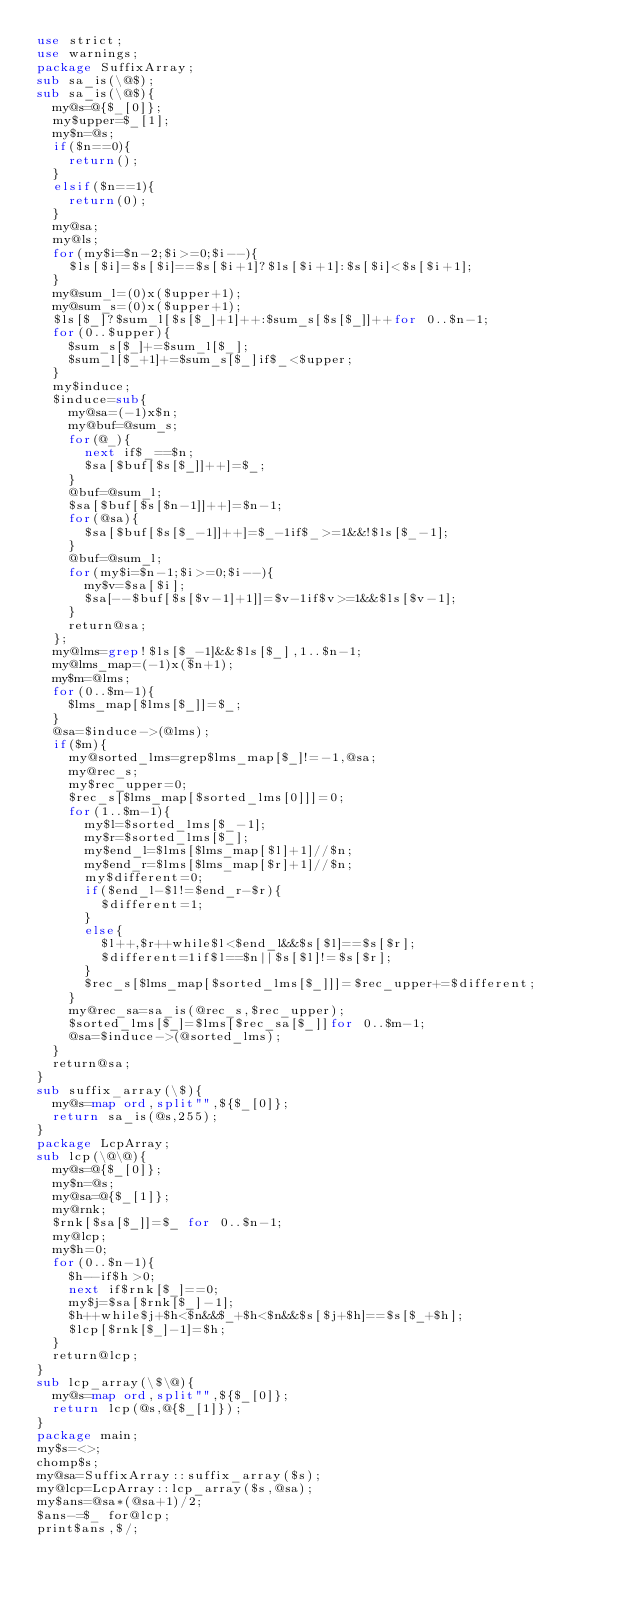<code> <loc_0><loc_0><loc_500><loc_500><_Perl_>use strict;
use warnings;
package SuffixArray;
sub sa_is(\@$);
sub sa_is(\@$){
	my@s=@{$_[0]};
	my$upper=$_[1];
	my$n=@s;
	if($n==0){
		return();
	}
	elsif($n==1){
		return(0);
	}
	my@sa;
	my@ls;
	for(my$i=$n-2;$i>=0;$i--){
		$ls[$i]=$s[$i]==$s[$i+1]?$ls[$i+1]:$s[$i]<$s[$i+1];
	}
	my@sum_l=(0)x($upper+1);
	my@sum_s=(0)x($upper+1);
	$ls[$_]?$sum_l[$s[$_]+1]++:$sum_s[$s[$_]]++for 0..$n-1;
	for(0..$upper){
		$sum_s[$_]+=$sum_l[$_];
		$sum_l[$_+1]+=$sum_s[$_]if$_<$upper;
	}
	my$induce;
	$induce=sub{
		my@sa=(-1)x$n;
		my@buf=@sum_s;
		for(@_){
			next if$_==$n;
			$sa[$buf[$s[$_]]++]=$_;
		}
		@buf=@sum_l;
		$sa[$buf[$s[$n-1]]++]=$n-1;
		for(@sa){
			$sa[$buf[$s[$_-1]]++]=$_-1if$_>=1&&!$ls[$_-1];
		}
		@buf=@sum_l;
		for(my$i=$n-1;$i>=0;$i--){
			my$v=$sa[$i];
			$sa[--$buf[$s[$v-1]+1]]=$v-1if$v>=1&&$ls[$v-1];
		}
		return@sa;
	};
	my@lms=grep!$ls[$_-1]&&$ls[$_],1..$n-1;
	my@lms_map=(-1)x($n+1);
	my$m=@lms;
	for(0..$m-1){
		$lms_map[$lms[$_]]=$_;
	}
	@sa=$induce->(@lms);
	if($m){
		my@sorted_lms=grep$lms_map[$_]!=-1,@sa;
		my@rec_s;
		my$rec_upper=0;
		$rec_s[$lms_map[$sorted_lms[0]]]=0;
		for(1..$m-1){
			my$l=$sorted_lms[$_-1];
			my$r=$sorted_lms[$_];
			my$end_l=$lms[$lms_map[$l]+1]//$n;
			my$end_r=$lms[$lms_map[$r]+1]//$n;
			my$different=0;
			if($end_l-$l!=$end_r-$r){
				$different=1;
			}
			else{
				$l++,$r++while$l<$end_l&&$s[$l]==$s[$r];
				$different=1if$l==$n||$s[$l]!=$s[$r];
			}
			$rec_s[$lms_map[$sorted_lms[$_]]]=$rec_upper+=$different;
		}
		my@rec_sa=sa_is(@rec_s,$rec_upper);
		$sorted_lms[$_]=$lms[$rec_sa[$_]]for 0..$m-1;
		@sa=$induce->(@sorted_lms);
	}
	return@sa;
}
sub suffix_array(\$){
	my@s=map ord,split"",${$_[0]};
	return sa_is(@s,255);
}
package LcpArray;
sub lcp(\@\@){
	my@s=@{$_[0]};
	my$n=@s;
	my@sa=@{$_[1]};
	my@rnk;
	$rnk[$sa[$_]]=$_ for 0..$n-1;
	my@lcp;
	my$h=0;
	for(0..$n-1){
		$h--if$h>0;
		next if$rnk[$_]==0;
		my$j=$sa[$rnk[$_]-1];
		$h++while$j+$h<$n&&$_+$h<$n&&$s[$j+$h]==$s[$_+$h];
		$lcp[$rnk[$_]-1]=$h;
	}
	return@lcp;
}
sub lcp_array(\$\@){
	my@s=map ord,split"",${$_[0]};
	return lcp(@s,@{$_[1]});
}
package main;
my$s=<>;
chomp$s;
my@sa=SuffixArray::suffix_array($s);
my@lcp=LcpArray::lcp_array($s,@sa);
my$ans=@sa*(@sa+1)/2;
$ans-=$_ for@lcp;
print$ans,$/;
</code> 